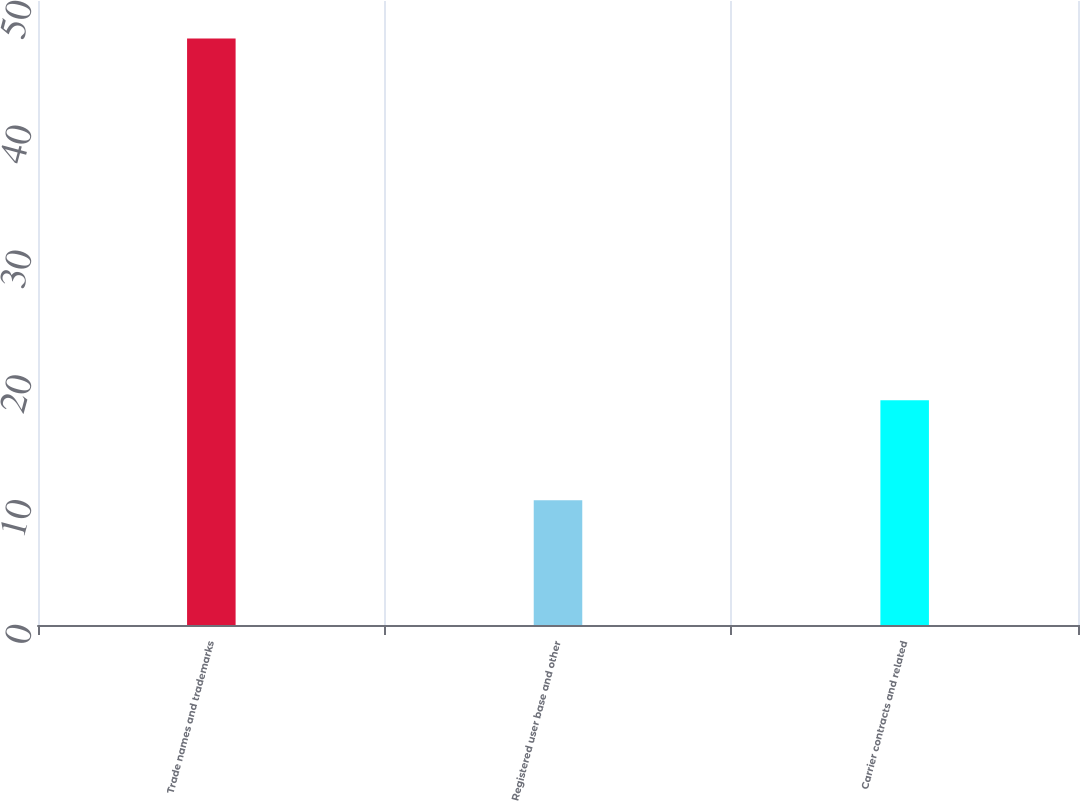Convert chart to OTSL. <chart><loc_0><loc_0><loc_500><loc_500><bar_chart><fcel>Trade names and trademarks<fcel>Registered user base and other<fcel>Carrier contracts and related<nl><fcel>47<fcel>10<fcel>18<nl></chart> 